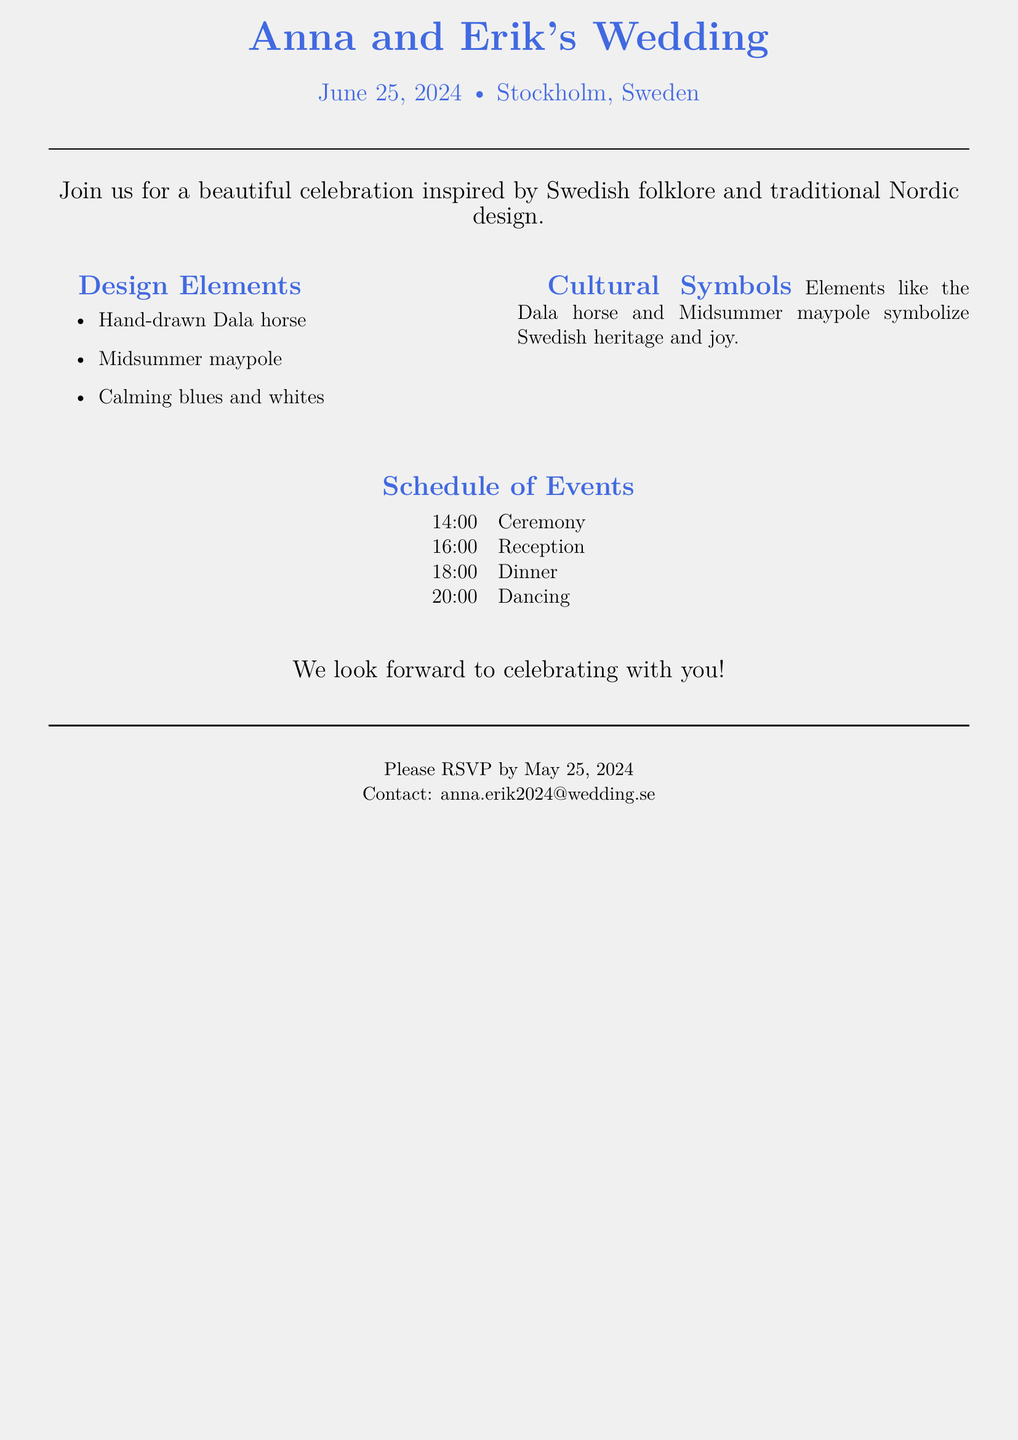What is the couple's name? The couple's names are prominently displayed at the top of the invitation.
Answer: Anna and Erik What is the wedding date? The date of the wedding is specified below the couple's names.
Answer: June 25, 2024 Where is the wedding taking place? The location of the wedding is mentioned in proximity to the date.
Answer: Stockholm, Sweden What time does the ceremony start? The scheduled event times are listed in a table, with the ceremony starting details.
Answer: 14:00 What cultural symbols are featured in the invitation? Cultural symbols mentioned are highlighted under the design elements section.
Answer: Dala horse and Midsummer maypole What is the RSVP deadline? The RSVP deadline is clearly stated near the end of the invitation.
Answer: May 25, 2024 What type of design theme is used for the invitation? The invitation describes its design theme directly in the introductory statement.
Answer: Traditional Nordic Theme How many events are listed in the schedule? The document lists events in a table format, providing a count of organized activities.
Answer: Four What color palette is used in the invitation? The color palette is defined in the design elements section.
Answer: Blues and whites 